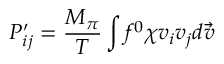Convert formula to latex. <formula><loc_0><loc_0><loc_500><loc_500>P _ { i j } ^ { \prime } = \frac { M _ { \pi } } { T } \int f ^ { 0 } \chi v _ { i } v _ { j } d \vec { v }</formula> 